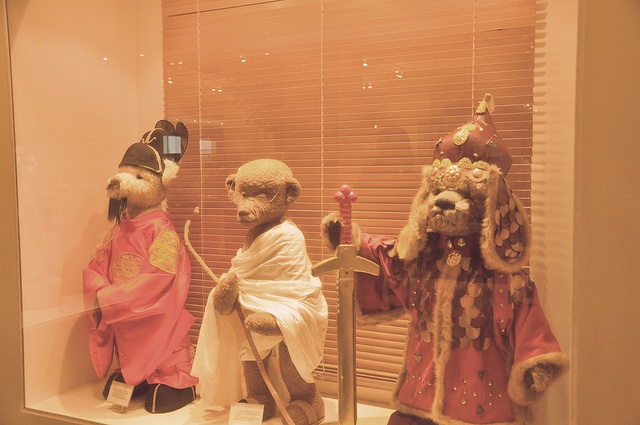Describe the objects in this image and their specific colors. I can see teddy bear in tan, salmon, brown, and maroon tones, teddy bear in tan and brown tones, and teddy bear in tan, maroon, and brown tones in this image. 